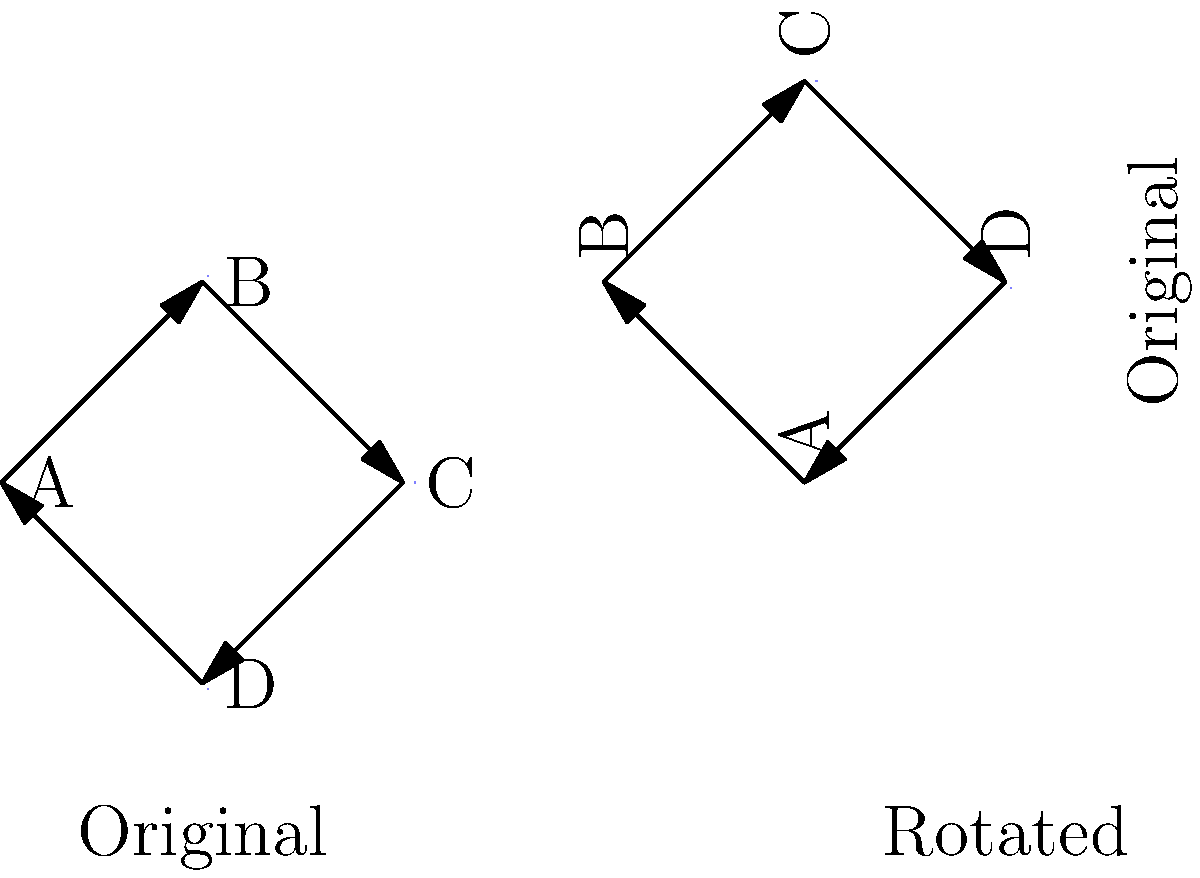In a computer network topology diagram, nodes A, B, C, and D are connected in a ring configuration. If the diagram is rotated 90 degrees clockwise, which node will be at the top position? To solve this problem, we need to follow these steps:

1. Identify the original positions of the nodes:
   - Node A is at the bottom left
   - Node B is at the top
   - Node C is at the bottom right
   - Node D is at the bottom center

2. Visualize a 90-degree clockwise rotation:
   - The top position (currently occupied by B) will move to the right
   - The right position (currently occupied by C) will move to the bottom
   - The bottom position (currently shared by A and D) will move to the left
   - The left position (currently unoccupied) will become the new top

3. Track the movement of each node:
   - A moves from bottom left to left
   - B moves from top to right
   - C moves from bottom right to bottom
   - D moves from bottom center to left

4. Identify which node ends up at the top position:
   - The left position in the original diagram becomes the top position after rotation
   - Node A was closest to the left position in the original diagram

Therefore, after a 90-degree clockwise rotation, node A will be at the top position.
Answer: A 